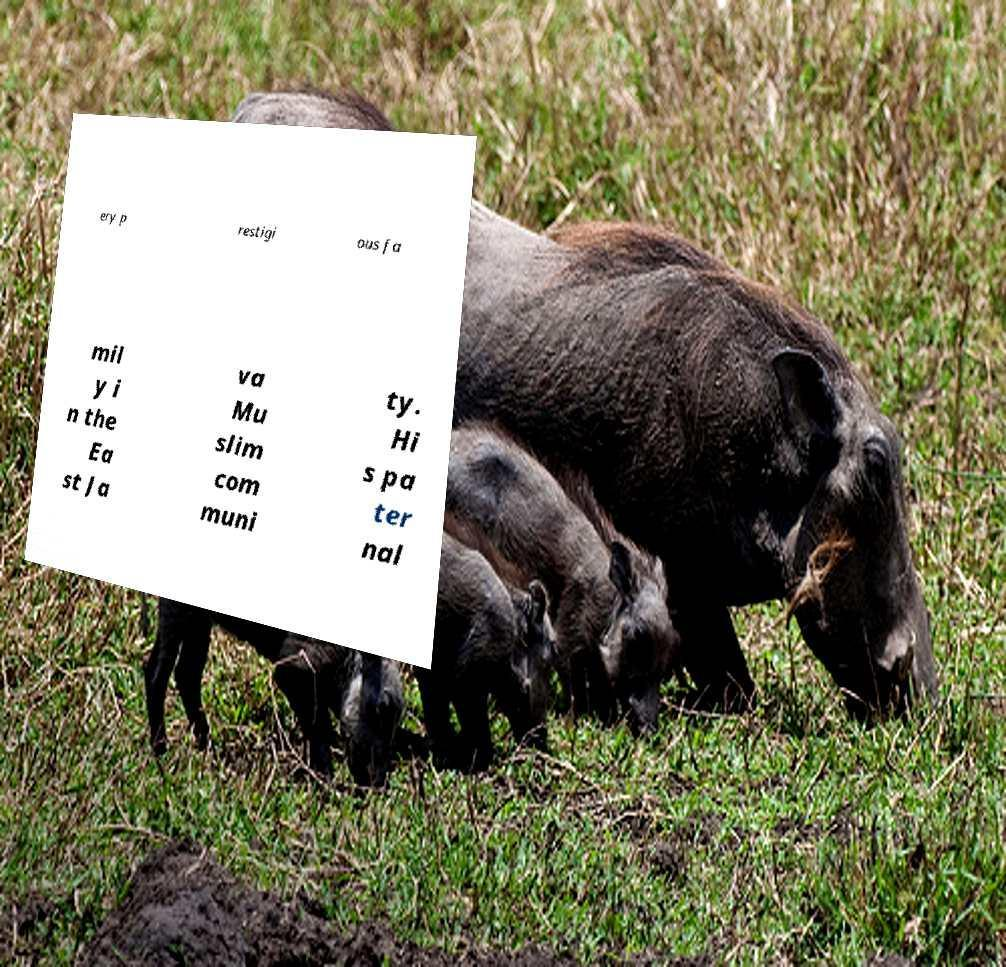Please identify and transcribe the text found in this image. ery p restigi ous fa mil y i n the Ea st Ja va Mu slim com muni ty. Hi s pa ter nal 